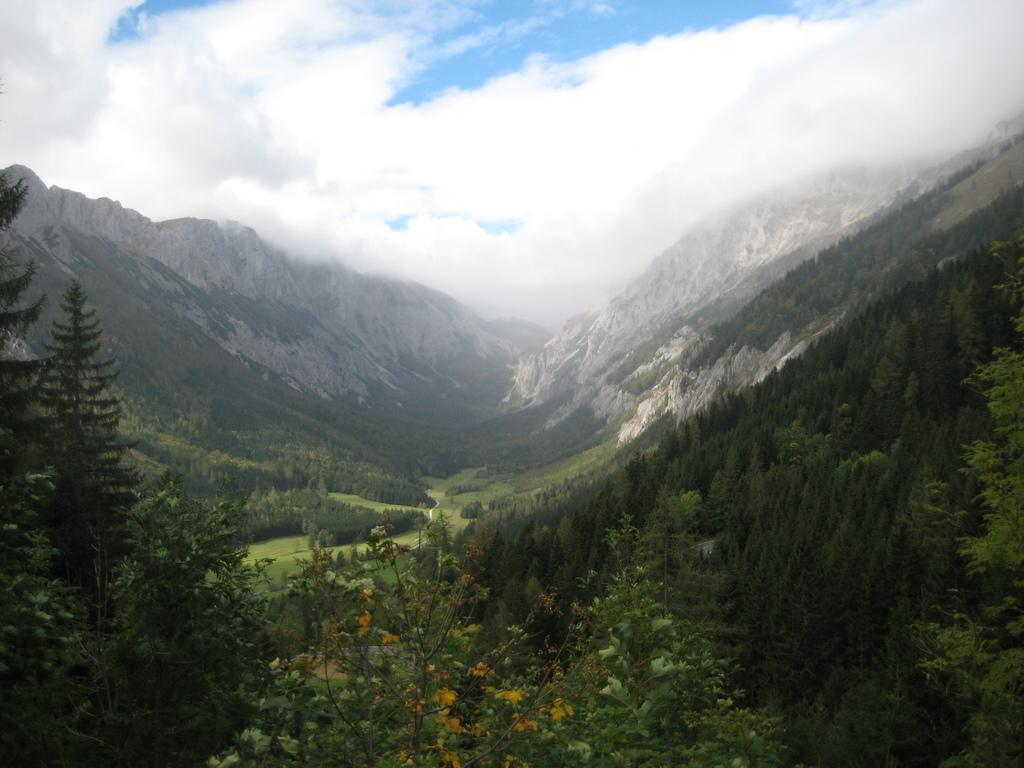What type of natural landform can be seen in the image? There are mountains in the image. What type of vegetation is present in the image? There are plants, trees, and grass in the image. What is visible in the sky in the image? There are clouds in the sky in the image. How many chickens are swimming in the water near the mountains in the image? There are no chickens or water visible in the image; it features mountains, plants, trees, grass, and clouds. Is there a jail visible in the image? There is no jail present in the image. 